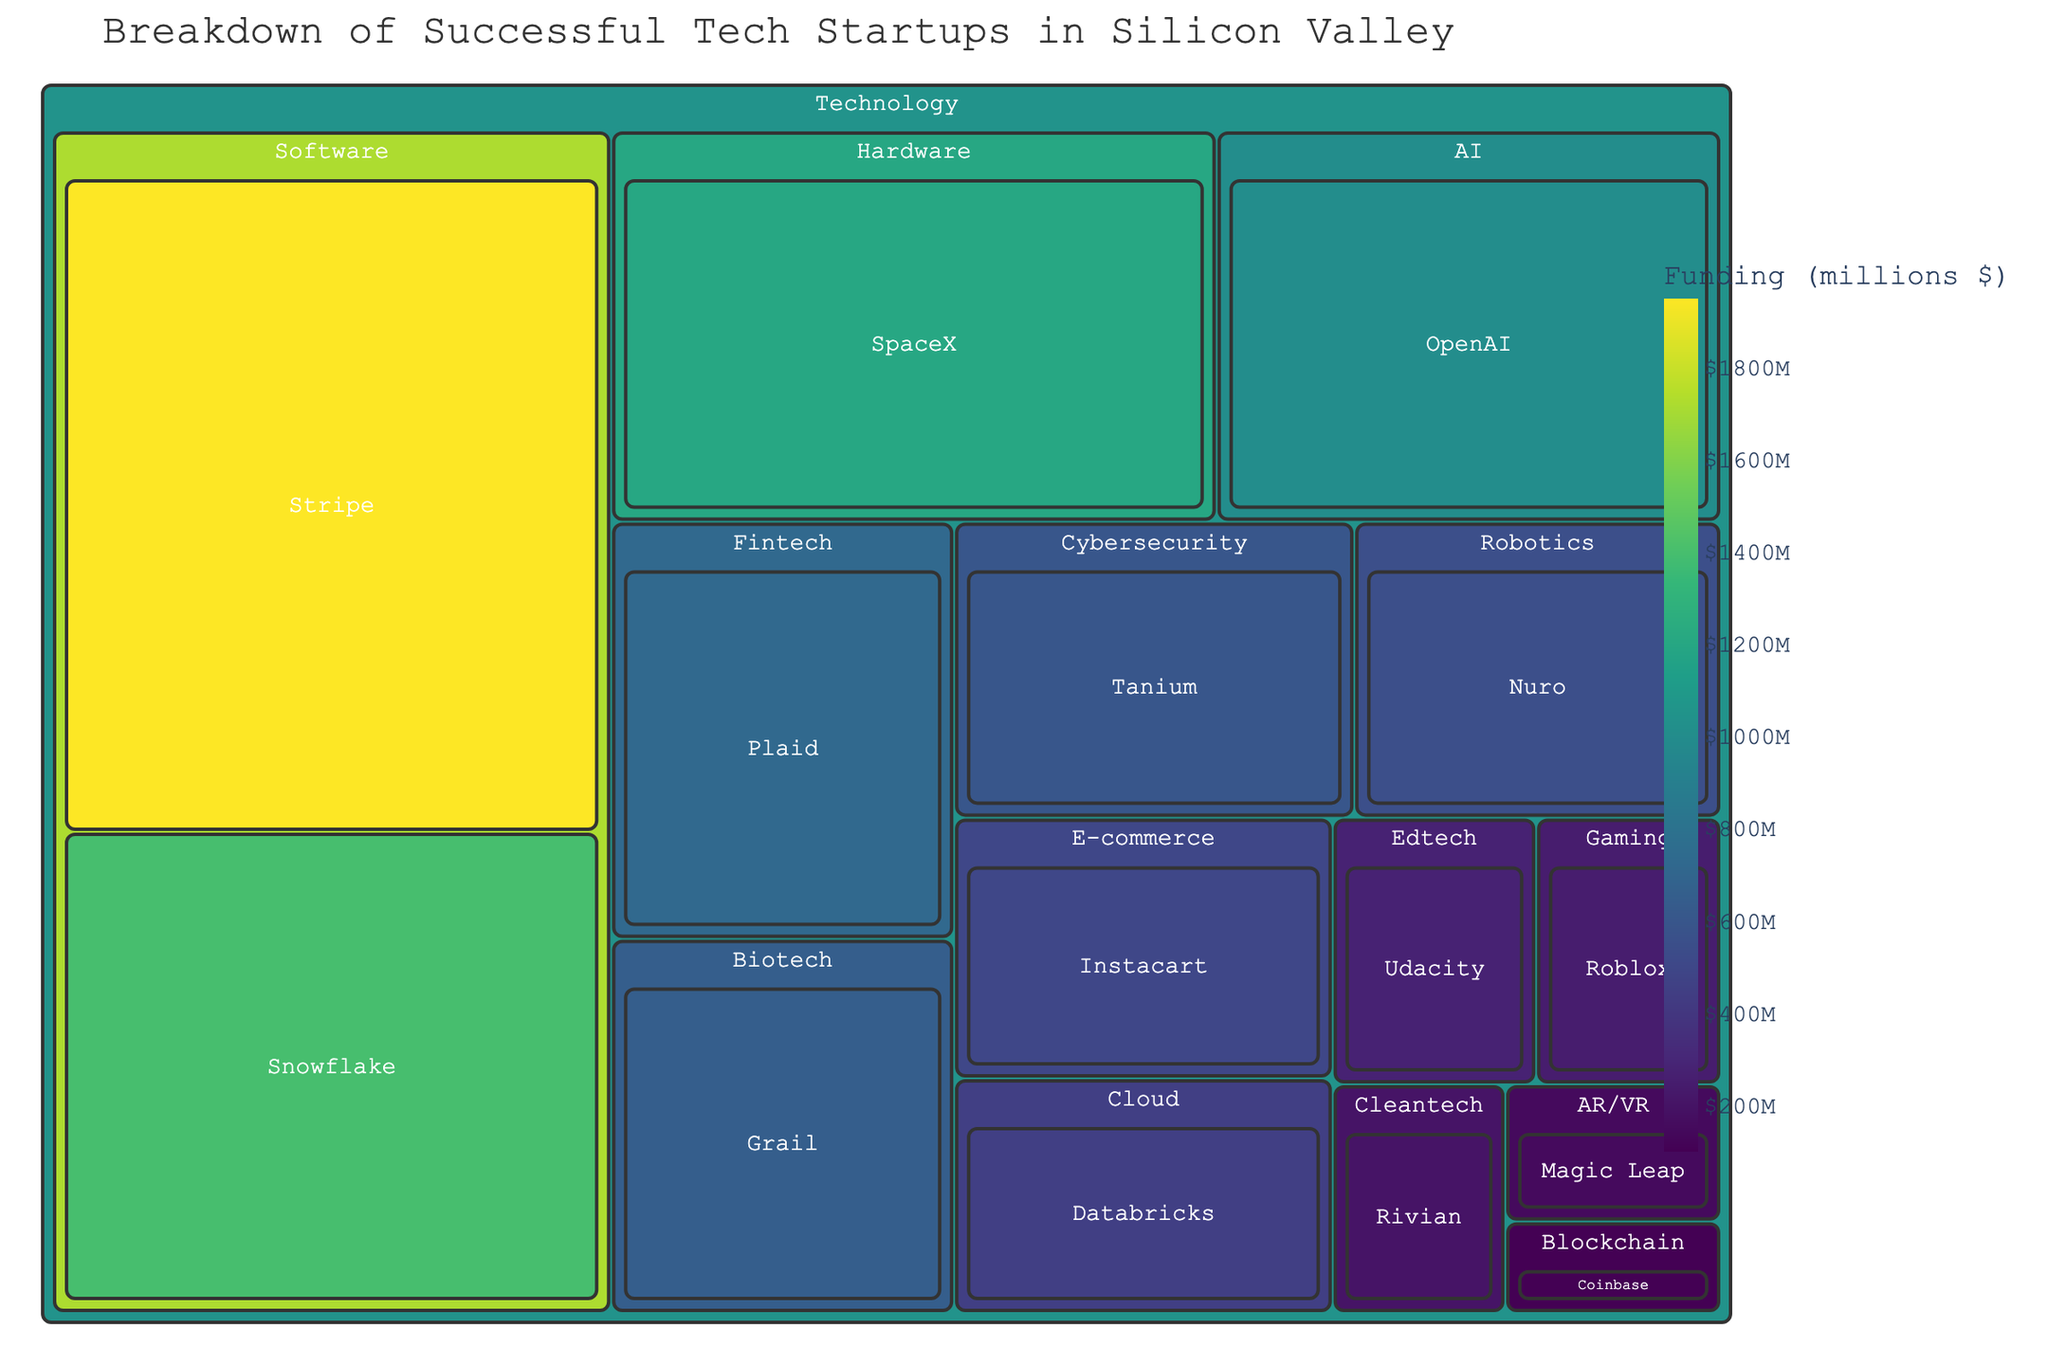What is the title of the figure? The title is typically displayed prominently at the top of the figure. In this case, it shows the overall subject and focus of the visual.
Answer: Breakdown of Successful Tech Startups in Silicon Valley Which startup received the highest amount of funding? By examining the size and color (indicating funding amount) of the blocks in the figure, the largest and darkest block represents Stripe.
Answer: Stripe How many sectors are represented under the Technology industry? Count the number of unique sectors (distinct groups) under the Technology category in the treemap.
Answer: 14 What is the total funding amount for the Software sector? Identify the blocks under the Software sector and sum their funding amounts: Stripe ($1950M) + Snowflake ($1400M). Thus, the total is 1950 + 1400 = 3350.
Answer: $3350M Which sector has more funding, Cybersecurity or AI? Compare the sizes and shades of the respective blocks for Cybersecurity (Tanium, $600M) and AI (OpenAI, $1000M). The funding amounts clearly show AI has more funding.
Answer: AI What is the average funding amount for E-commerce and Edtech sectors? Calculate the average by summing the funding amounts of the E-commerce (Instacart, $500M) and Edtech (Udacity, $275M) sectors and dividing by 2. The total funding is 500 + 275 = 775, and the average is 775 / 2 = 387.5.
Answer: $387.5M Compare the funding between Magic Leap and Coinbase. Which one received more funding and by how much? Look at the funding amounts for Magic Leap (AR/VR, $150M) and Coinbase (Blockchain, $100M). Calculate the difference: 150 - 100 = 50. Thus, Magic Leap received $50M more.
Answer: Magic Leap, $50M What is the total funding amount represented in the treemap? Sum the funding amounts of all startups in the figure. This is a more detailed calculation: 1950 + 1400 + 1200 + 1000 + 725 + 650 + 600 + 550 + 500 + 450 + 275 + 250 + 200 + 150 + 100 = 10000.
Answer: $10000M Which sector has the least amount of funding and how much? Identify the smallest block with the lightest color which represents the sector with the least funding. In this case, it's the Blockchain sector with Coinbase at $100M.
Answer: Blockchain, $100M 